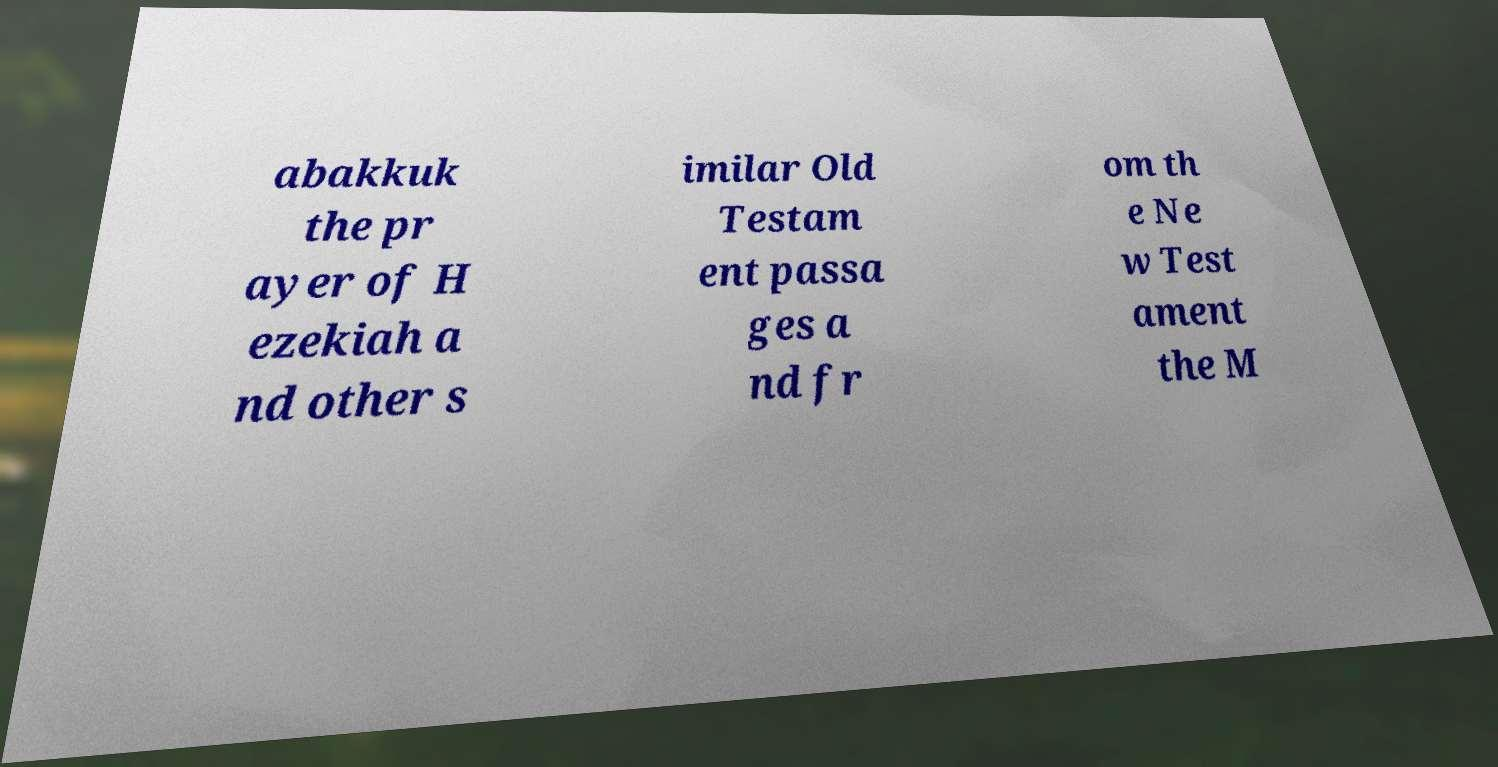Please read and relay the text visible in this image. What does it say? abakkuk the pr ayer of H ezekiah a nd other s imilar Old Testam ent passa ges a nd fr om th e Ne w Test ament the M 